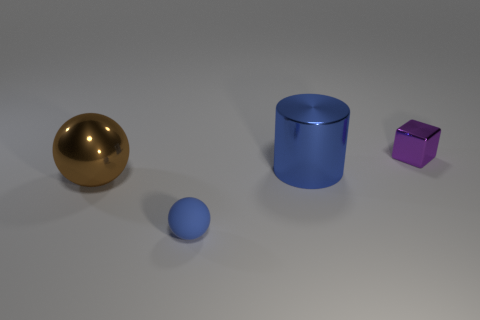Does the ball that is behind the tiny matte sphere have the same material as the blue object in front of the shiny sphere?
Your answer should be very brief. No. The blue thing that is in front of the sphere to the left of the small object to the left of the purple block is what shape?
Provide a short and direct response. Sphere. Are there more big brown metallic objects than tiny blue matte cylinders?
Make the answer very short. Yes. Are there any tiny rubber things?
Your response must be concise. Yes. What number of objects are things in front of the small purple shiny block or blue objects behind the small blue sphere?
Offer a terse response. 3. Does the metallic block have the same color as the big cylinder?
Make the answer very short. No. Is the number of large objects less than the number of small shiny blocks?
Offer a terse response. No. Are there any blue rubber things behind the cube?
Keep it short and to the point. No. Does the brown ball have the same material as the tiny blue object?
Your answer should be compact. No. There is another thing that is the same shape as the matte object; what color is it?
Offer a terse response. Brown. 